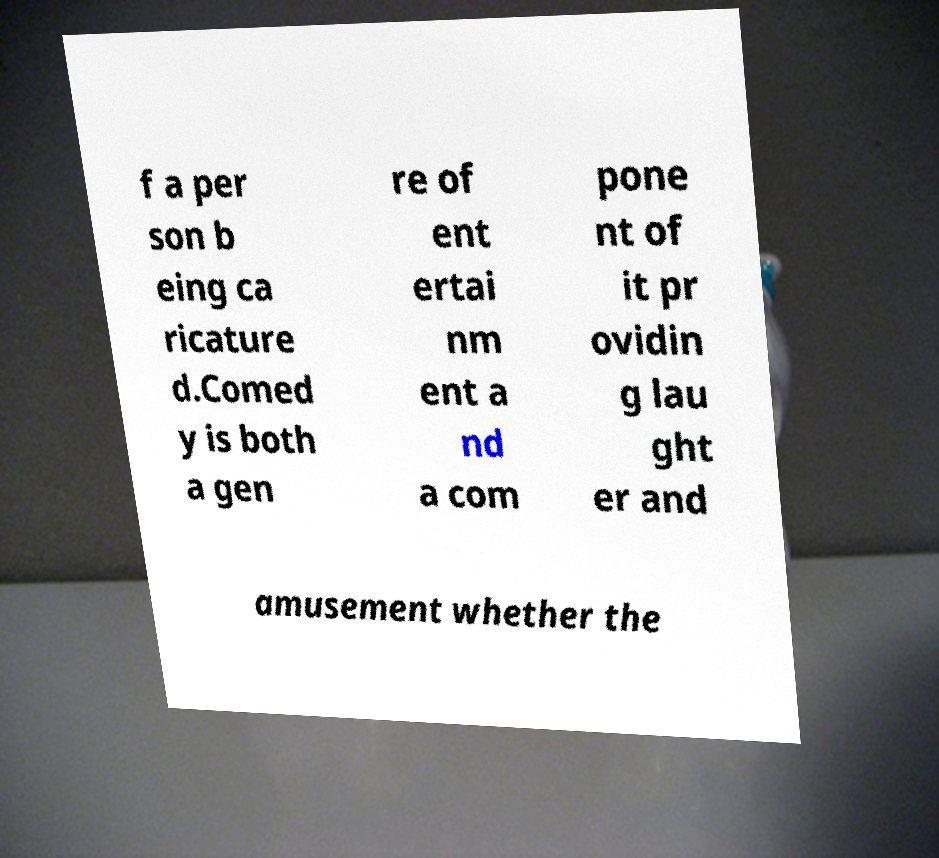There's text embedded in this image that I need extracted. Can you transcribe it verbatim? f a per son b eing ca ricature d.Comed y is both a gen re of ent ertai nm ent a nd a com pone nt of it pr ovidin g lau ght er and amusement whether the 